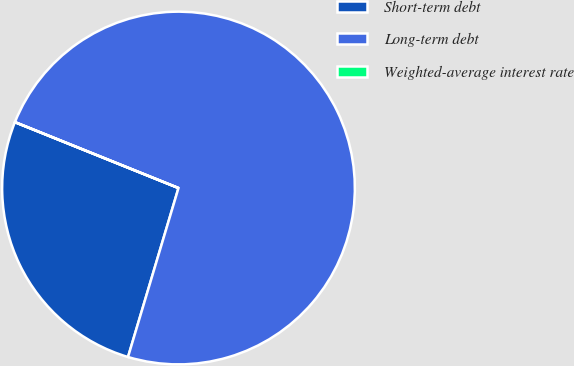Convert chart. <chart><loc_0><loc_0><loc_500><loc_500><pie_chart><fcel>Short-term debt<fcel>Long-term debt<fcel>Weighted-average interest rate<nl><fcel>26.47%<fcel>73.52%<fcel>0.01%<nl></chart> 